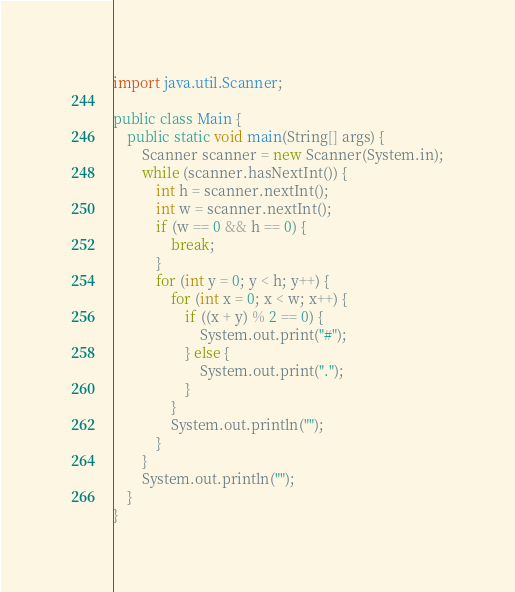Convert code to text. <code><loc_0><loc_0><loc_500><loc_500><_Java_>import java.util.Scanner;

public class Main {
    public static void main(String[] args) {
        Scanner scanner = new Scanner(System.in);
        while (scanner.hasNextInt()) {
            int h = scanner.nextInt();
            int w = scanner.nextInt();
            if (w == 0 && h == 0) {
                break;
            }
            for (int y = 0; y < h; y++) {
                for (int x = 0; x < w; x++) {
                    if ((x + y) % 2 == 0) {
                        System.out.print("#");
                    } else {
                        System.out.print(".");
                    }
                }
                System.out.println("");
            }
        }
        System.out.println("");
    }
}

</code> 